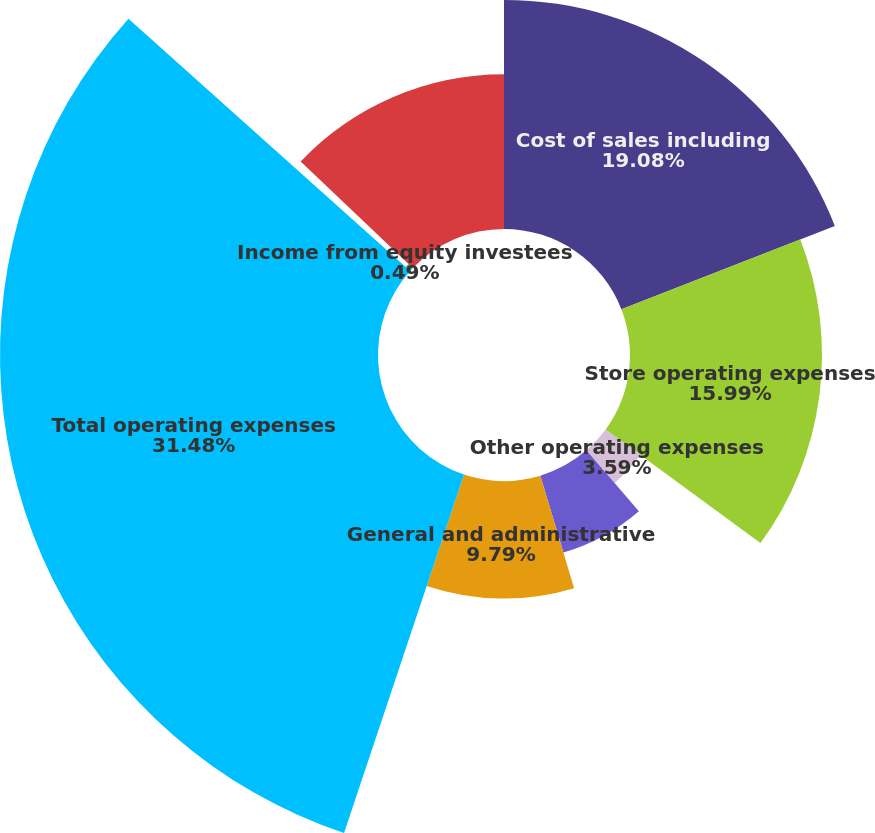<chart> <loc_0><loc_0><loc_500><loc_500><pie_chart><fcel>Cost of sales including<fcel>Store operating expenses<fcel>Other operating expenses<fcel>Depreciation and amortization<fcel>General and administrative<fcel>Total operating expenses<fcel>Income from equity investees<fcel>Operating income<nl><fcel>19.08%<fcel>15.99%<fcel>3.59%<fcel>6.69%<fcel>9.79%<fcel>31.48%<fcel>0.49%<fcel>12.89%<nl></chart> 